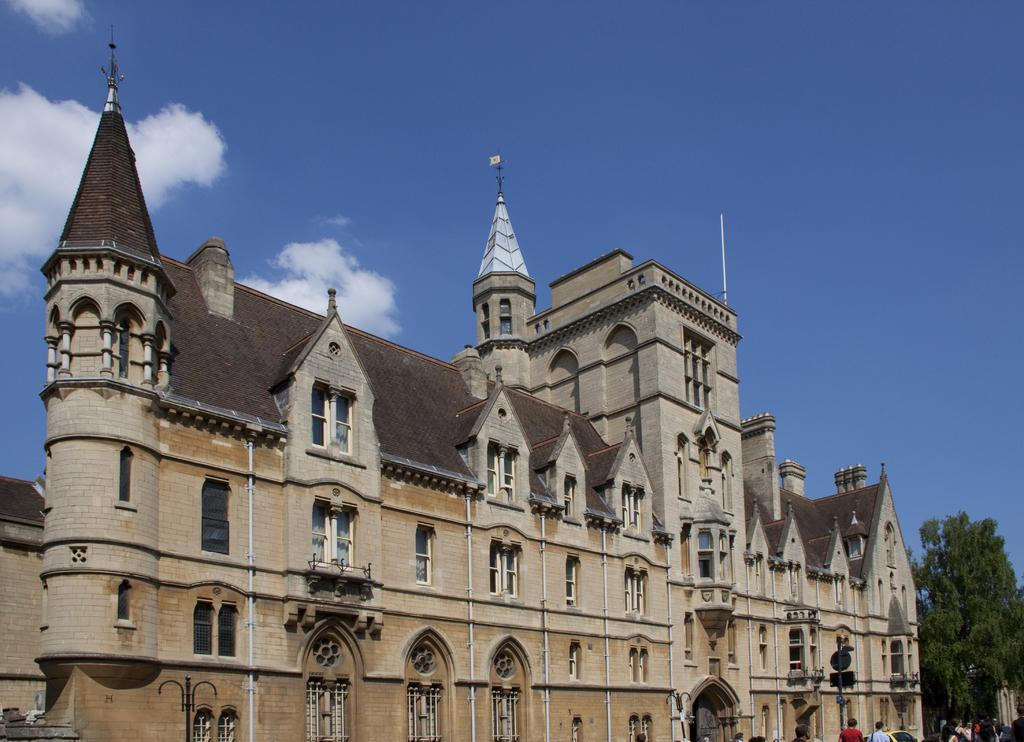What type of structure is present in the image? There is a building in the image. What colors are used on the building? The building has cream and brown colors. What are the people in the image doing? There are people walking in the image. What type of vegetation can be seen in the image? There are trees with green color in the image. What colors can be seen in the sky in the image? The sky has blue and white colors in the image. What is the name of the airport in the image? There is no airport present in the image, so it is not possible to determine its name. 